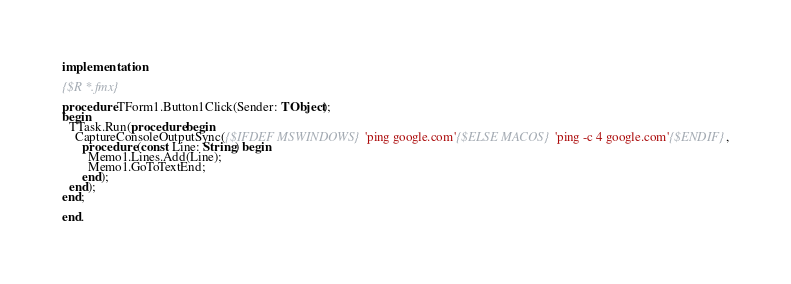Convert code to text. <code><loc_0><loc_0><loc_500><loc_500><_Pascal_>
implementation

{$R *.fmx}

procedure TForm1.Button1Click(Sender: TObject);
begin
  TTask.Run(procedure begin
    CaptureConsoleOutputSync({$IFDEF MSWINDOWS}'ping google.com'{$ELSE MACOS}'ping -c 4 google.com'{$ENDIF},
      procedure (const Line: String) begin
        Memo1.Lines.Add(Line);
        Memo1.GoToTextEnd;
      end);
  end);
end;

end.
</code> 